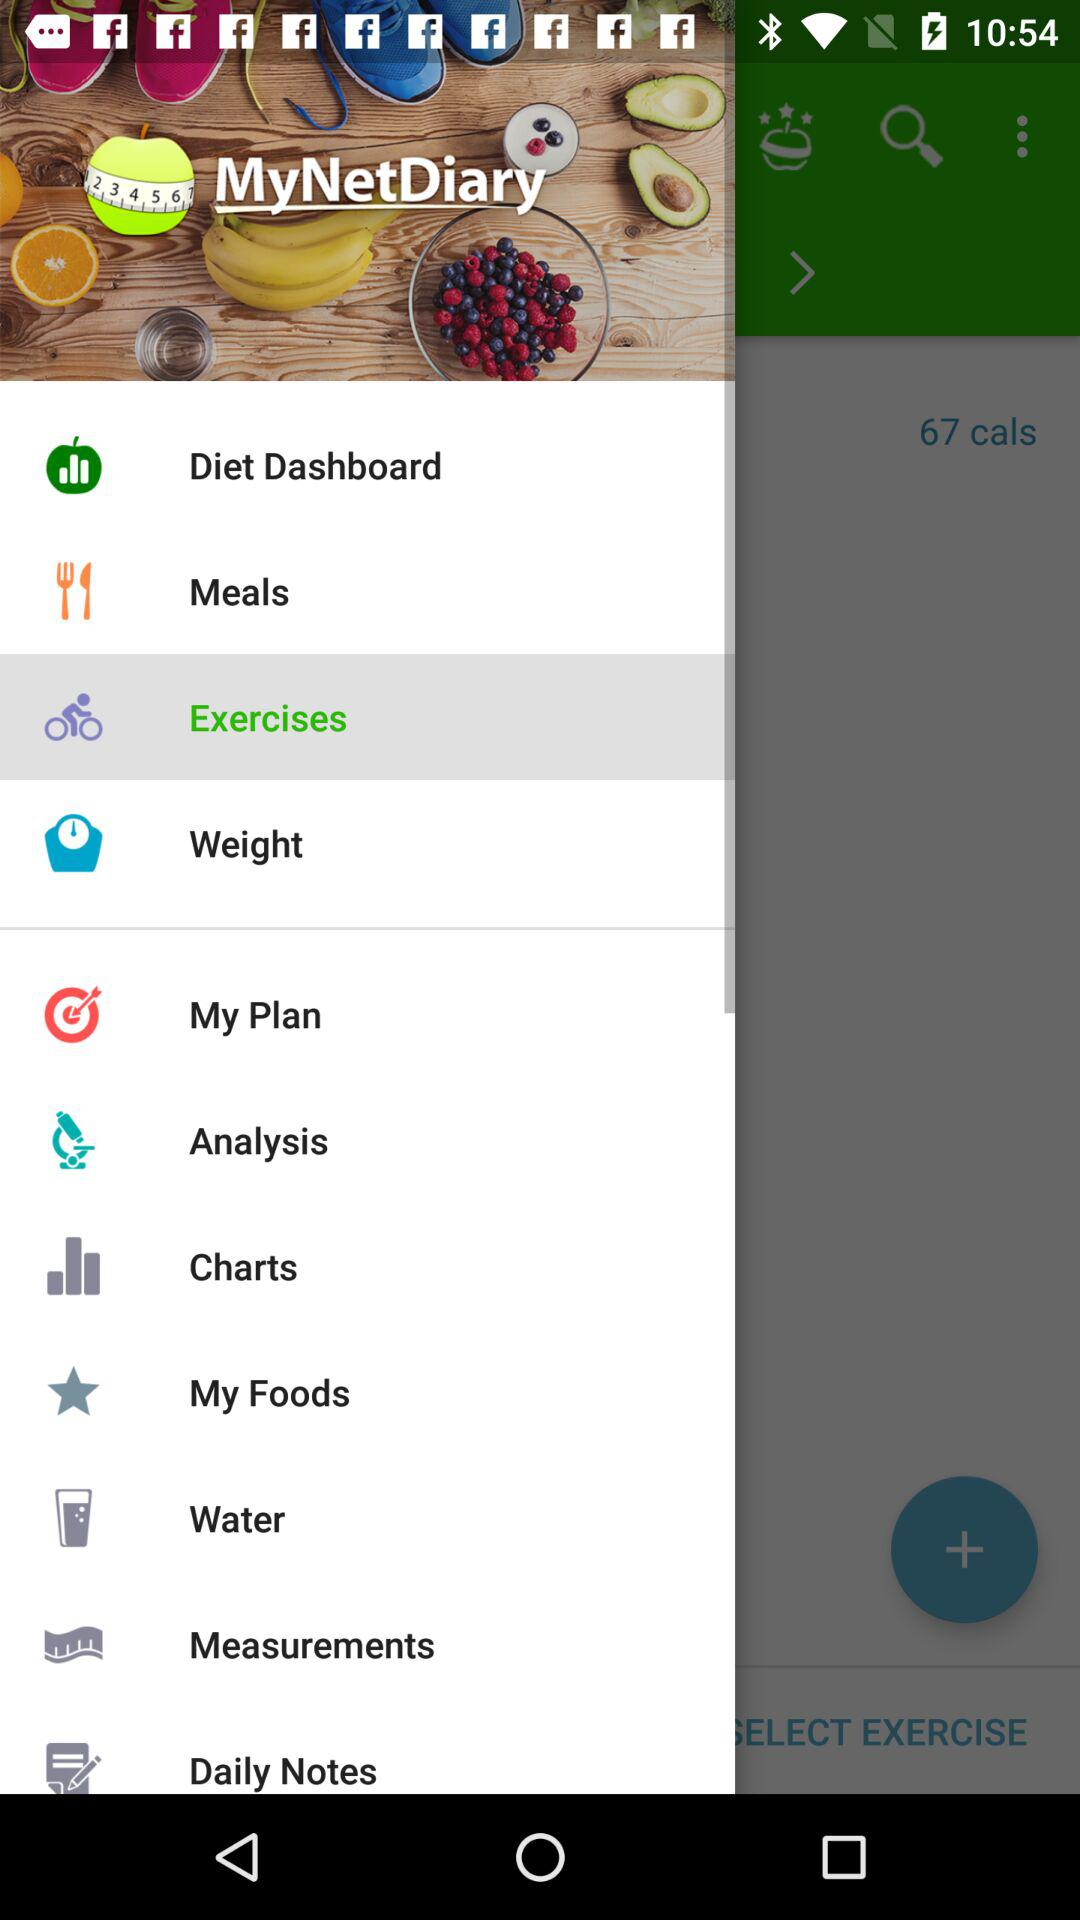What is the application name? The application name is "MyNetDiary". 